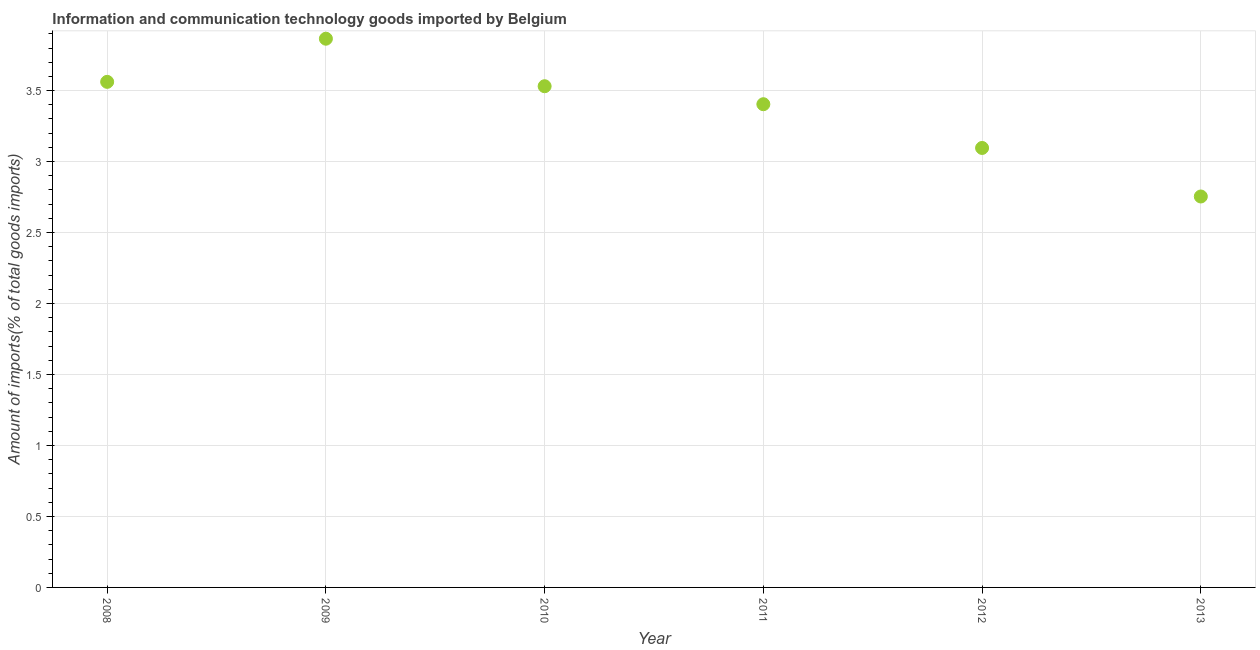What is the amount of ict goods imports in 2011?
Ensure brevity in your answer.  3.4. Across all years, what is the maximum amount of ict goods imports?
Offer a very short reply. 3.87. Across all years, what is the minimum amount of ict goods imports?
Ensure brevity in your answer.  2.75. In which year was the amount of ict goods imports maximum?
Give a very brief answer. 2009. What is the sum of the amount of ict goods imports?
Ensure brevity in your answer.  20.21. What is the difference between the amount of ict goods imports in 2012 and 2013?
Your answer should be compact. 0.34. What is the average amount of ict goods imports per year?
Keep it short and to the point. 3.37. What is the median amount of ict goods imports?
Your response must be concise. 3.47. Do a majority of the years between 2013 and 2010 (inclusive) have amount of ict goods imports greater than 2.8 %?
Your answer should be very brief. Yes. What is the ratio of the amount of ict goods imports in 2010 to that in 2013?
Keep it short and to the point. 1.28. Is the difference between the amount of ict goods imports in 2010 and 2012 greater than the difference between any two years?
Your answer should be compact. No. What is the difference between the highest and the second highest amount of ict goods imports?
Make the answer very short. 0.3. What is the difference between the highest and the lowest amount of ict goods imports?
Provide a short and direct response. 1.11. Does the amount of ict goods imports monotonically increase over the years?
Offer a terse response. No. How many dotlines are there?
Make the answer very short. 1. Does the graph contain grids?
Provide a succinct answer. Yes. What is the title of the graph?
Make the answer very short. Information and communication technology goods imported by Belgium. What is the label or title of the X-axis?
Make the answer very short. Year. What is the label or title of the Y-axis?
Your answer should be compact. Amount of imports(% of total goods imports). What is the Amount of imports(% of total goods imports) in 2008?
Offer a terse response. 3.56. What is the Amount of imports(% of total goods imports) in 2009?
Keep it short and to the point. 3.87. What is the Amount of imports(% of total goods imports) in 2010?
Provide a succinct answer. 3.53. What is the Amount of imports(% of total goods imports) in 2011?
Provide a succinct answer. 3.4. What is the Amount of imports(% of total goods imports) in 2012?
Offer a terse response. 3.1. What is the Amount of imports(% of total goods imports) in 2013?
Your answer should be very brief. 2.75. What is the difference between the Amount of imports(% of total goods imports) in 2008 and 2009?
Your response must be concise. -0.3. What is the difference between the Amount of imports(% of total goods imports) in 2008 and 2010?
Ensure brevity in your answer.  0.03. What is the difference between the Amount of imports(% of total goods imports) in 2008 and 2011?
Keep it short and to the point. 0.16. What is the difference between the Amount of imports(% of total goods imports) in 2008 and 2012?
Keep it short and to the point. 0.47. What is the difference between the Amount of imports(% of total goods imports) in 2008 and 2013?
Give a very brief answer. 0.81. What is the difference between the Amount of imports(% of total goods imports) in 2009 and 2010?
Offer a terse response. 0.33. What is the difference between the Amount of imports(% of total goods imports) in 2009 and 2011?
Offer a very short reply. 0.46. What is the difference between the Amount of imports(% of total goods imports) in 2009 and 2012?
Make the answer very short. 0.77. What is the difference between the Amount of imports(% of total goods imports) in 2009 and 2013?
Your answer should be compact. 1.11. What is the difference between the Amount of imports(% of total goods imports) in 2010 and 2011?
Offer a terse response. 0.13. What is the difference between the Amount of imports(% of total goods imports) in 2010 and 2012?
Provide a short and direct response. 0.43. What is the difference between the Amount of imports(% of total goods imports) in 2010 and 2013?
Your response must be concise. 0.78. What is the difference between the Amount of imports(% of total goods imports) in 2011 and 2012?
Your response must be concise. 0.31. What is the difference between the Amount of imports(% of total goods imports) in 2011 and 2013?
Keep it short and to the point. 0.65. What is the difference between the Amount of imports(% of total goods imports) in 2012 and 2013?
Offer a terse response. 0.34. What is the ratio of the Amount of imports(% of total goods imports) in 2008 to that in 2009?
Ensure brevity in your answer.  0.92. What is the ratio of the Amount of imports(% of total goods imports) in 2008 to that in 2011?
Provide a short and direct response. 1.05. What is the ratio of the Amount of imports(% of total goods imports) in 2008 to that in 2012?
Your response must be concise. 1.15. What is the ratio of the Amount of imports(% of total goods imports) in 2008 to that in 2013?
Give a very brief answer. 1.29. What is the ratio of the Amount of imports(% of total goods imports) in 2009 to that in 2010?
Your answer should be compact. 1.09. What is the ratio of the Amount of imports(% of total goods imports) in 2009 to that in 2011?
Your answer should be very brief. 1.14. What is the ratio of the Amount of imports(% of total goods imports) in 2009 to that in 2012?
Provide a succinct answer. 1.25. What is the ratio of the Amount of imports(% of total goods imports) in 2009 to that in 2013?
Offer a terse response. 1.4. What is the ratio of the Amount of imports(% of total goods imports) in 2010 to that in 2012?
Keep it short and to the point. 1.14. What is the ratio of the Amount of imports(% of total goods imports) in 2010 to that in 2013?
Your response must be concise. 1.28. What is the ratio of the Amount of imports(% of total goods imports) in 2011 to that in 2013?
Offer a very short reply. 1.24. What is the ratio of the Amount of imports(% of total goods imports) in 2012 to that in 2013?
Offer a very short reply. 1.12. 